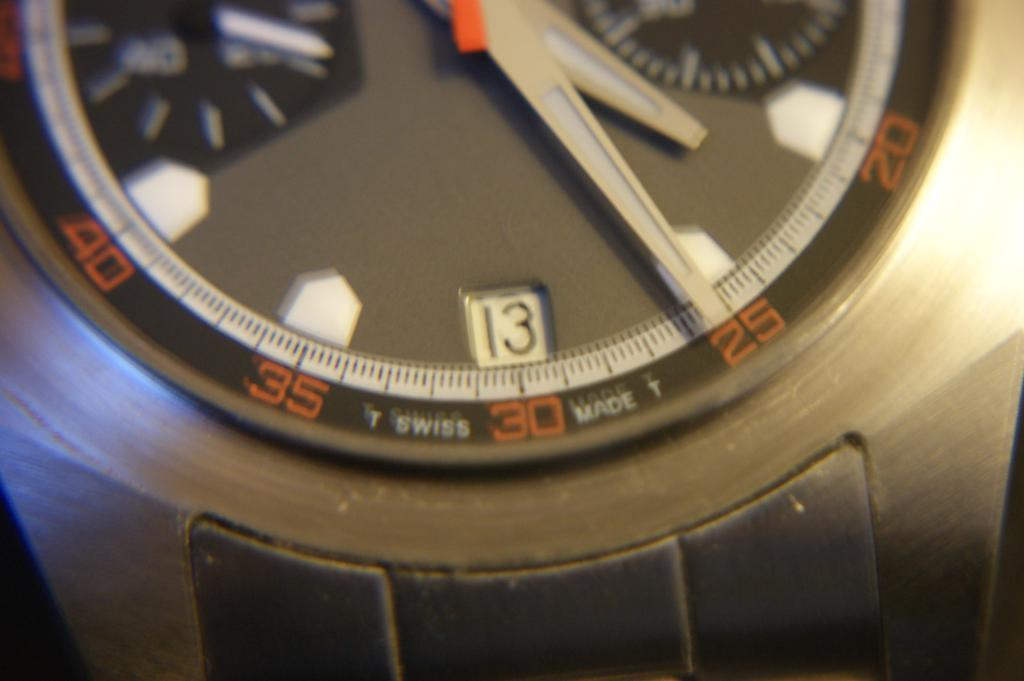<image>
Write a terse but informative summary of the picture. a close up of a watch face reads Swiss Made 